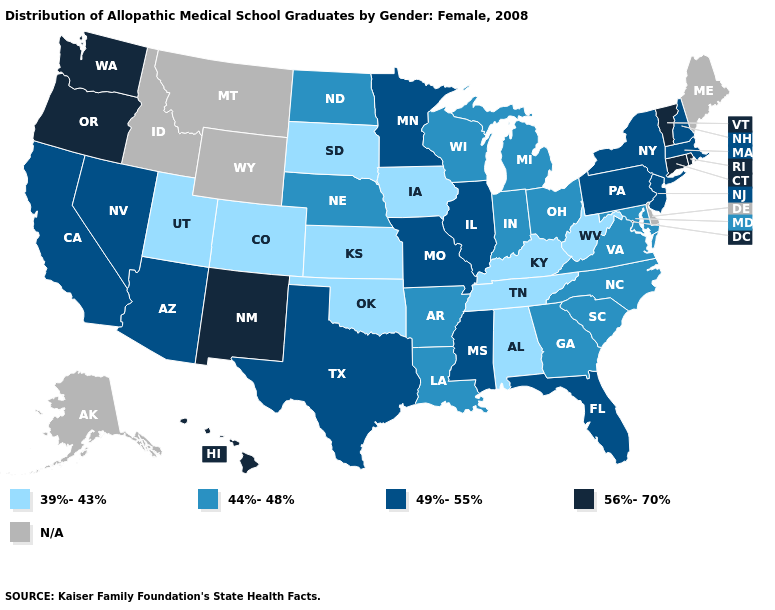Name the states that have a value in the range 49%-55%?
Short answer required. Arizona, California, Florida, Illinois, Massachusetts, Minnesota, Mississippi, Missouri, Nevada, New Hampshire, New Jersey, New York, Pennsylvania, Texas. Among the states that border Oregon , which have the highest value?
Be succinct. Washington. Which states have the lowest value in the West?
Write a very short answer. Colorado, Utah. What is the lowest value in the West?
Short answer required. 39%-43%. What is the value of Idaho?
Keep it brief. N/A. Does West Virginia have the lowest value in the South?
Keep it brief. Yes. Which states have the lowest value in the Northeast?
Write a very short answer. Massachusetts, New Hampshire, New Jersey, New York, Pennsylvania. What is the value of Washington?
Write a very short answer. 56%-70%. Name the states that have a value in the range 49%-55%?
Give a very brief answer. Arizona, California, Florida, Illinois, Massachusetts, Minnesota, Mississippi, Missouri, Nevada, New Hampshire, New Jersey, New York, Pennsylvania, Texas. What is the value of Illinois?
Quick response, please. 49%-55%. What is the value of Virginia?
Write a very short answer. 44%-48%. Name the states that have a value in the range 39%-43%?
Quick response, please. Alabama, Colorado, Iowa, Kansas, Kentucky, Oklahoma, South Dakota, Tennessee, Utah, West Virginia. What is the value of Maryland?
Quick response, please. 44%-48%. Among the states that border Pennsylvania , does Maryland have the lowest value?
Quick response, please. No. What is the lowest value in the MidWest?
Short answer required. 39%-43%. 